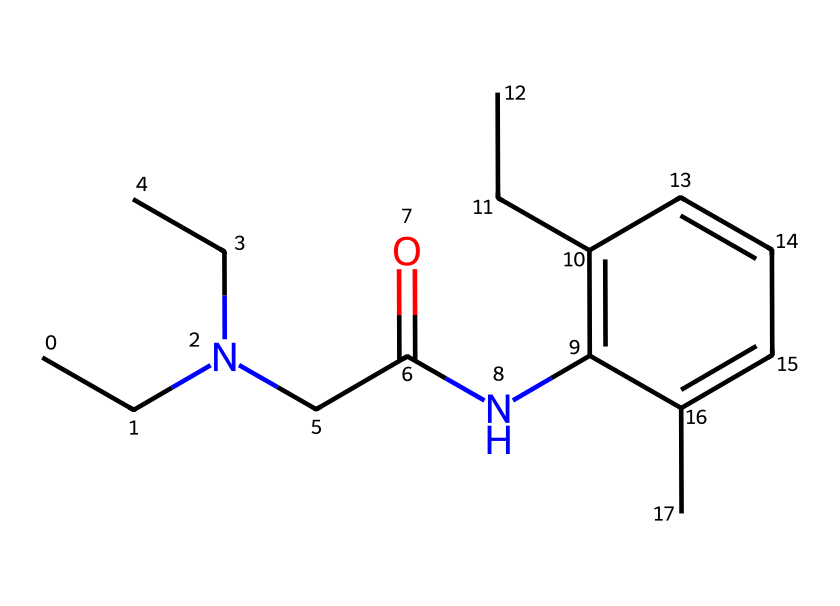What is the total number of carbon atoms in this structure? To determine the total number of carbon atoms, we count the 'C' entries and carbon atoms in each structural portion of the SMILES representation. There are 16 carbon atoms present in the chemical structure.
Answer: 16 How many nitrogen atoms are there in the molecule? By analyzing the SMILES notation, we identify one 'N' entry indicating there is one nitrogen atom in the chemical structure.
Answer: 1 What type of functional group is present due to the 'NC(=O)' part of the structure? The 'NC(=O)' notation indicates the presence of an amide functional group, characterized by the presence of a carbonyl (C=O) directly bonded to a nitrogen atom.
Answer: amide Is this compound classified as a base or an acid based on its primary amine? The presence of the nitrogen bonded to two carbon chains (CCN(CC)) indicates it is a basic amine rather than an acidic component, as it can accept protons.
Answer: base What role does this compound play in cosmetics? Lidocaine is commonly used in cosmetic formulations as a topical anesthetic to relieve muscle pain or provide numbing effects on the skin.
Answer: anesthetic How many rings are present in the structure? In the SMILES representation, there is a 'c' letter indicating aromatic carbons, and by looking at the arrangement, we can see that there is one aromatic ring.
Answer: 1 